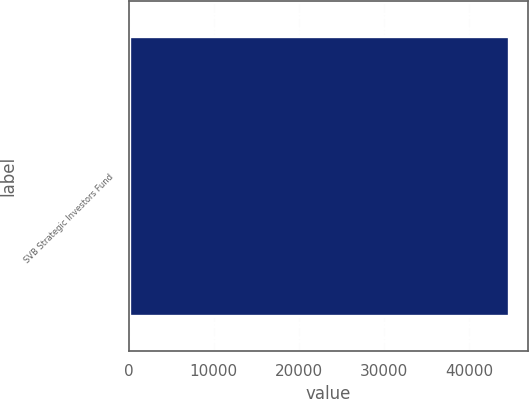<chart> <loc_0><loc_0><loc_500><loc_500><bar_chart><fcel>SVB Strategic Investors Fund<nl><fcel>44736<nl></chart> 